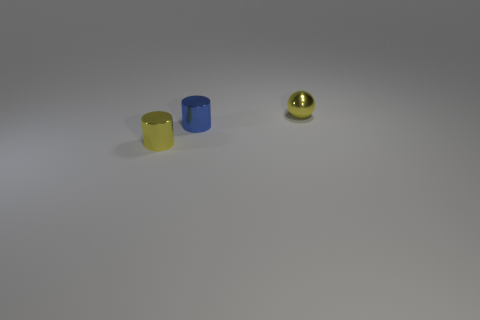Add 3 yellow metallic objects. How many objects exist? 6 Subtract all balls. How many objects are left? 2 Add 3 tiny yellow metallic spheres. How many tiny yellow metallic spheres exist? 4 Subtract 1 yellow cylinders. How many objects are left? 2 Subtract all large green rubber spheres. Subtract all small objects. How many objects are left? 0 Add 2 tiny yellow metallic spheres. How many tiny yellow metallic spheres are left? 3 